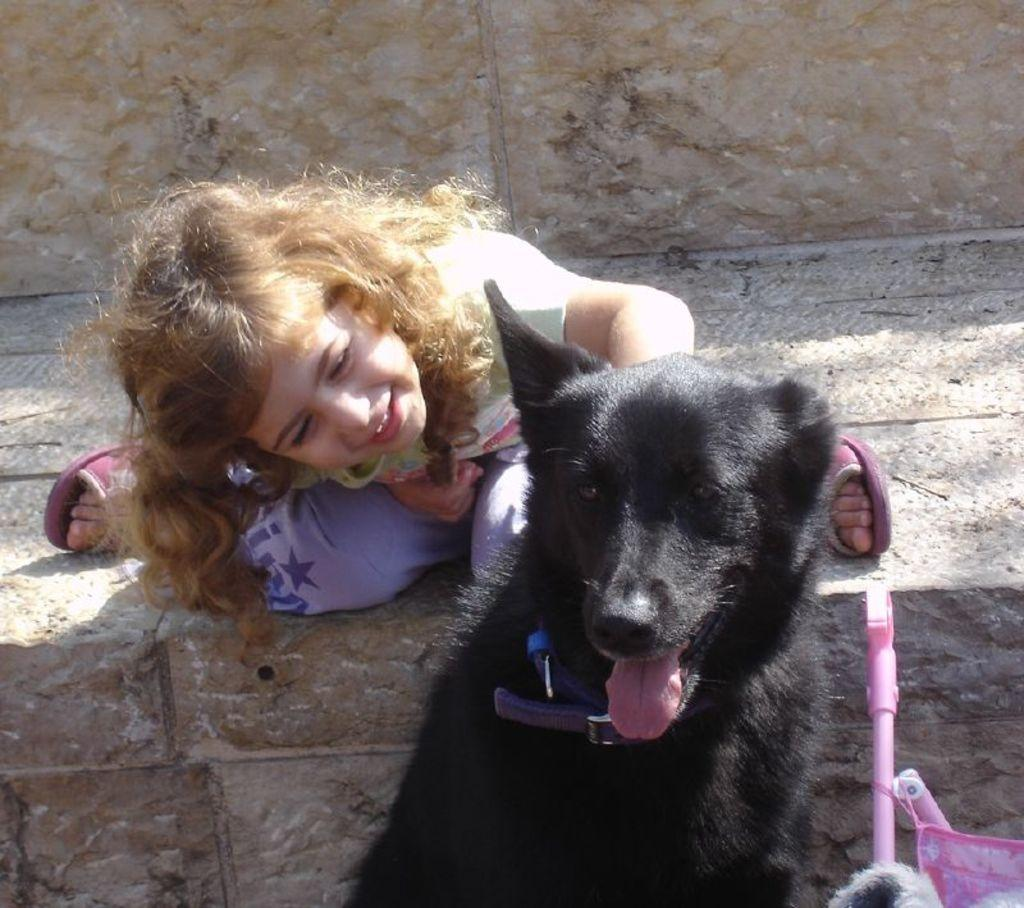What type of animal is in the image? There is a black dog in the image. What is the girl in the image doing? The girl is sitting on the floor in the image. What type of cattle can be seen in the image? There is no cattle present in the image; it features a black dog and a girl sitting on the floor. What invention is being used by the girl in the image? There is no invention being used by the girl in the image; she is simply sitting on the floor. 